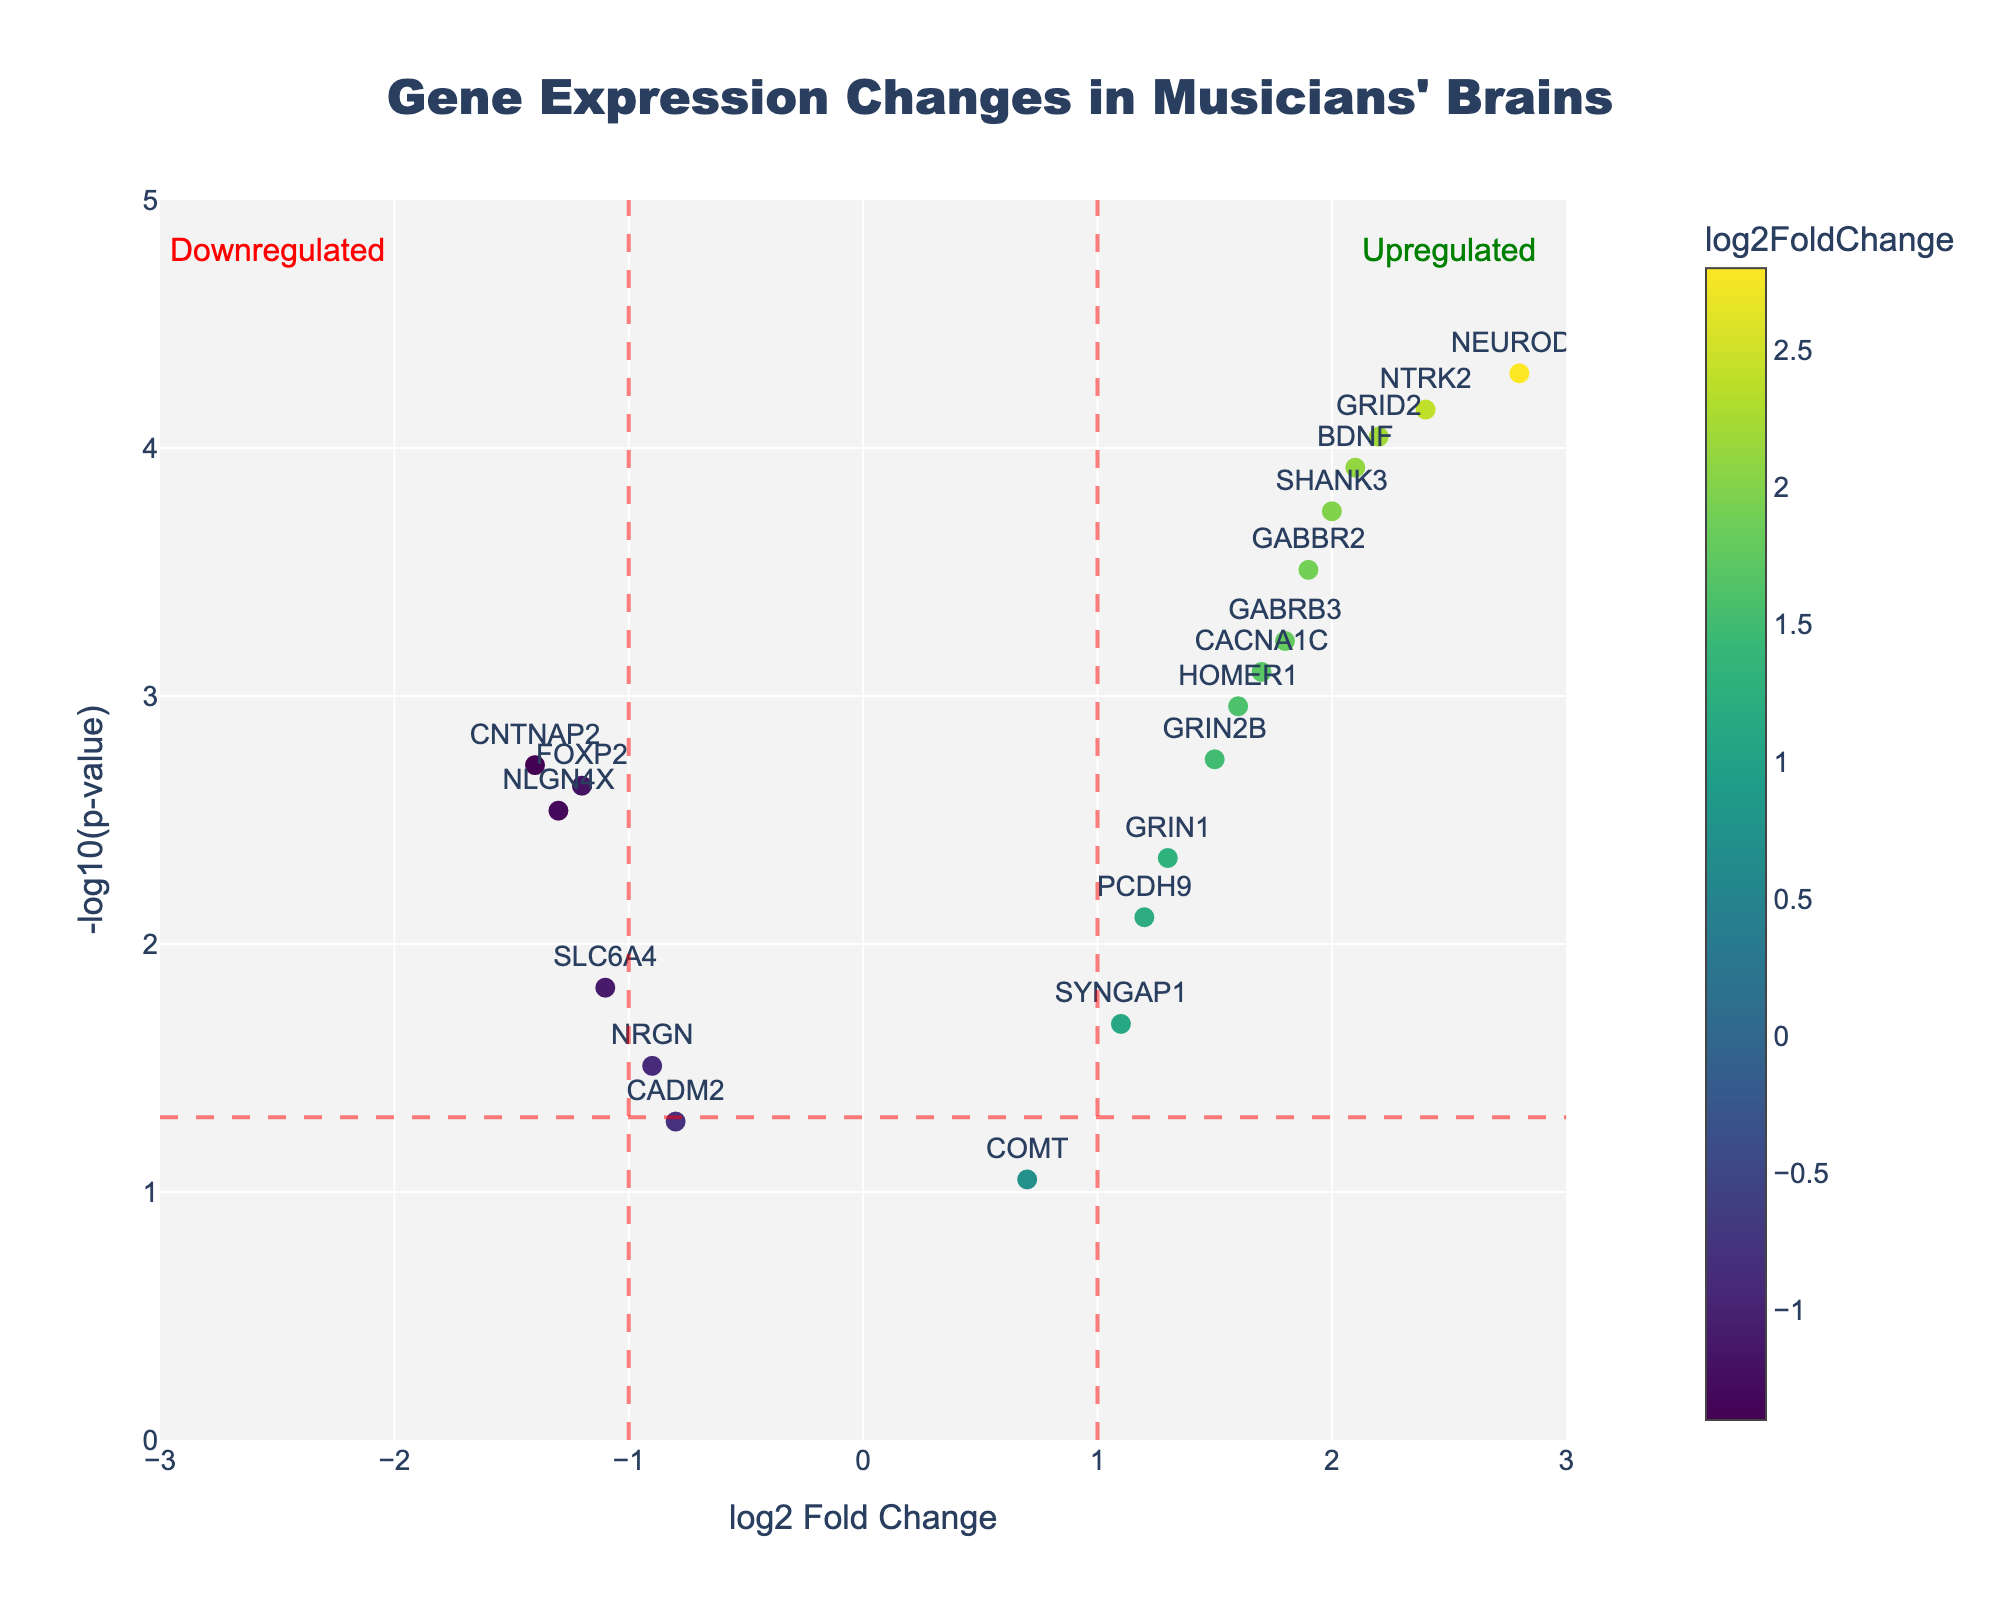What is the title of the plot? The title of the plot is usually displayed at the top of the figure. In this case, it's mentioned in the layout settings as "Gene Expression Changes in Musicians' Brains".
Answer: Gene Expression Changes in Musicians' Brains How many genes are displayed in the plot? By counting the number of unique markers or text labels in the plot, we get the total number of genes displayed.
Answer: 20 Which gene has the highest log2 Fold Change? By locating the marker with the highest x-axis value (log2 Fold Change) in the plot, we find that NEUROD1 has the highest log2 Fold Change.
Answer: NEUROD1 Which gene has the lowest p-value? The lowest p-value corresponds to the highest y-axis value (-log10(p-value)). NEUROD1 has the highest value on the y-axis, indicating the lowest p-value.
Answer: NEUROD1 Which genes are considered upregulated according to the plot's annotations? Genes with a log2 Fold Change greater than 1 fall into the "upregulated" category, marked by the annotation. These genes include NEUROD1, BDNF, CACNA1C, GABBR2, NTRK2, GRID2, GABRB3, SHANK3, and HOMER1.
Answer: NEUROD1, BDNF, CACNA1C, GABBR2, NTRK2, GRID2, GABRB3, SHANK3, HOMER1 Which genes are considered significantly differentially expressed? Genes with a p-value less than 0.05 are marked by being above the horizontal red dashed line (-log10(0.05) = 1.301).
Answer: FOXP2, NEUROD1, GRIN2B, BDNF, CACNA1C, GRIN1, GABBR2, NTRK2, HOMER1, CNTNAP2, GRID2, GABRB3, SYNGAP1, NLGN4X, SHANK3 What is the log2 Fold Change and p-value of the FOXP2 gene? From the hovertext or labels, FOXP2 is shown with a log2 Fold Change of -1.2 and a p-value of 0.0023.
Answer: log2FC: -1.2, p-value: 0.0023 Which gene is downregulated and has one of the most significant p-values? Among the downregulated genes (log2 Fold Change < -1), CNTNAP2 has a highly significant p-value (near the top on the y-axis).
Answer: CNTNAP2 What quadrant of the plot does the HOMER1 gene fall into? By its position, HOMER1 has a positive log2 Fold Change and a significant p-value; hence, it falls into the upper right quadrant of the plot.
Answer: Upper right How many genes have a log2 Fold Change within the range -1 to 1 and are not considered upregulated or downregulated by the annotations? Counting the markers with log2 Fold Change between -1 and 1, the genes are COMT, PCDH9, CADM2, and SYNGAP1.
Answer: 4 